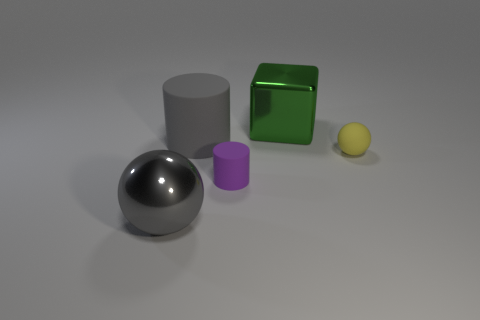There is a shiny thing on the right side of the purple thing; is it the same size as the big gray cylinder?
Your response must be concise. Yes. There is a object that is both on the left side of the yellow thing and right of the purple thing; what is its shape?
Ensure brevity in your answer.  Cube. Is the number of big blocks in front of the purple matte thing greater than the number of big gray cylinders?
Make the answer very short. No. The gray sphere that is the same material as the large cube is what size?
Offer a terse response. Large. What number of rubber things are the same color as the big sphere?
Keep it short and to the point. 1. There is a small thing to the left of the yellow ball; does it have the same color as the big matte cylinder?
Offer a terse response. No. Is the number of green cubes that are left of the gray metal ball the same as the number of gray rubber cylinders to the right of the tiny sphere?
Provide a succinct answer. Yes. Are there any other things that have the same material as the small yellow ball?
Offer a very short reply. Yes. What is the color of the large metallic object that is in front of the big gray cylinder?
Your answer should be compact. Gray. Is the number of large gray matte cylinders in front of the big gray metallic sphere the same as the number of purple cylinders?
Your answer should be very brief. No. 